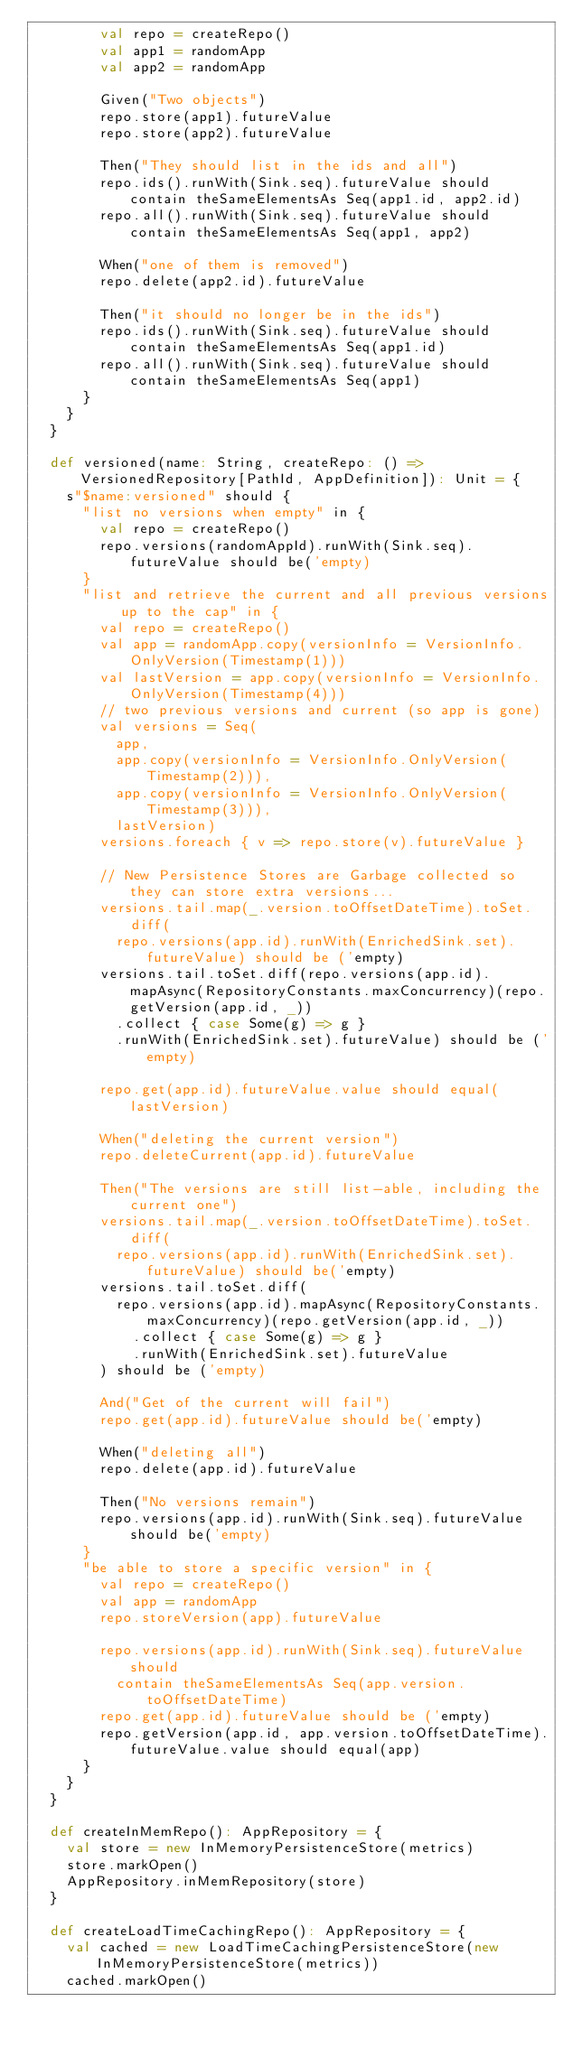Convert code to text. <code><loc_0><loc_0><loc_500><loc_500><_Scala_>        val repo = createRepo()
        val app1 = randomApp
        val app2 = randomApp

        Given("Two objects")
        repo.store(app1).futureValue
        repo.store(app2).futureValue

        Then("They should list in the ids and all")
        repo.ids().runWith(Sink.seq).futureValue should contain theSameElementsAs Seq(app1.id, app2.id)
        repo.all().runWith(Sink.seq).futureValue should contain theSameElementsAs Seq(app1, app2)

        When("one of them is removed")
        repo.delete(app2.id).futureValue

        Then("it should no longer be in the ids")
        repo.ids().runWith(Sink.seq).futureValue should contain theSameElementsAs Seq(app1.id)
        repo.all().runWith(Sink.seq).futureValue should contain theSameElementsAs Seq(app1)
      }
    }
  }

  def versioned(name: String, createRepo: () => VersionedRepository[PathId, AppDefinition]): Unit = {
    s"$name:versioned" should {
      "list no versions when empty" in {
        val repo = createRepo()
        repo.versions(randomAppId).runWith(Sink.seq).futureValue should be('empty)
      }
      "list and retrieve the current and all previous versions up to the cap" in {
        val repo = createRepo()
        val app = randomApp.copy(versionInfo = VersionInfo.OnlyVersion(Timestamp(1)))
        val lastVersion = app.copy(versionInfo = VersionInfo.OnlyVersion(Timestamp(4)))
        // two previous versions and current (so app is gone)
        val versions = Seq(
          app,
          app.copy(versionInfo = VersionInfo.OnlyVersion(Timestamp(2))),
          app.copy(versionInfo = VersionInfo.OnlyVersion(Timestamp(3))),
          lastVersion)
        versions.foreach { v => repo.store(v).futureValue }

        // New Persistence Stores are Garbage collected so they can store extra versions...
        versions.tail.map(_.version.toOffsetDateTime).toSet.diff(
          repo.versions(app.id).runWith(EnrichedSink.set).futureValue) should be ('empty)
        versions.tail.toSet.diff(repo.versions(app.id).mapAsync(RepositoryConstants.maxConcurrency)(repo.getVersion(app.id, _))
          .collect { case Some(g) => g }
          .runWith(EnrichedSink.set).futureValue) should be ('empty)

        repo.get(app.id).futureValue.value should equal(lastVersion)

        When("deleting the current version")
        repo.deleteCurrent(app.id).futureValue

        Then("The versions are still list-able, including the current one")
        versions.tail.map(_.version.toOffsetDateTime).toSet.diff(
          repo.versions(app.id).runWith(EnrichedSink.set).futureValue) should be('empty)
        versions.tail.toSet.diff(
          repo.versions(app.id).mapAsync(RepositoryConstants.maxConcurrency)(repo.getVersion(app.id, _))
            .collect { case Some(g) => g }
            .runWith(EnrichedSink.set).futureValue
        ) should be ('empty)

        And("Get of the current will fail")
        repo.get(app.id).futureValue should be('empty)

        When("deleting all")
        repo.delete(app.id).futureValue

        Then("No versions remain")
        repo.versions(app.id).runWith(Sink.seq).futureValue should be('empty)
      }
      "be able to store a specific version" in {
        val repo = createRepo()
        val app = randomApp
        repo.storeVersion(app).futureValue

        repo.versions(app.id).runWith(Sink.seq).futureValue should
          contain theSameElementsAs Seq(app.version.toOffsetDateTime)
        repo.get(app.id).futureValue should be ('empty)
        repo.getVersion(app.id, app.version.toOffsetDateTime).futureValue.value should equal(app)
      }
    }
  }

  def createInMemRepo(): AppRepository = {
    val store = new InMemoryPersistenceStore(metrics)
    store.markOpen()
    AppRepository.inMemRepository(store)
  }

  def createLoadTimeCachingRepo(): AppRepository = {
    val cached = new LoadTimeCachingPersistenceStore(new InMemoryPersistenceStore(metrics))
    cached.markOpen()</code> 